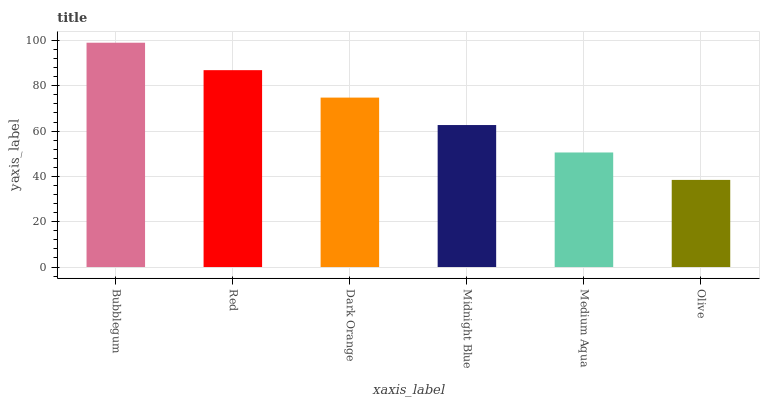Is Olive the minimum?
Answer yes or no. Yes. Is Bubblegum the maximum?
Answer yes or no. Yes. Is Red the minimum?
Answer yes or no. No. Is Red the maximum?
Answer yes or no. No. Is Bubblegum greater than Red?
Answer yes or no. Yes. Is Red less than Bubblegum?
Answer yes or no. Yes. Is Red greater than Bubblegum?
Answer yes or no. No. Is Bubblegum less than Red?
Answer yes or no. No. Is Dark Orange the high median?
Answer yes or no. Yes. Is Midnight Blue the low median?
Answer yes or no. Yes. Is Midnight Blue the high median?
Answer yes or no. No. Is Medium Aqua the low median?
Answer yes or no. No. 